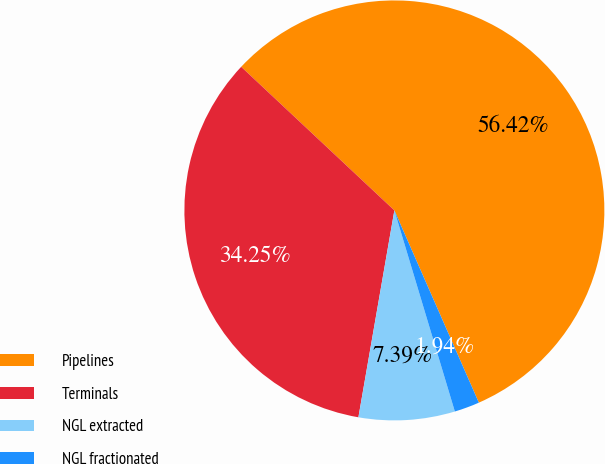Convert chart to OTSL. <chart><loc_0><loc_0><loc_500><loc_500><pie_chart><fcel>Pipelines<fcel>Terminals<fcel>NGL extracted<fcel>NGL fractionated<nl><fcel>56.43%<fcel>34.25%<fcel>7.39%<fcel>1.94%<nl></chart> 